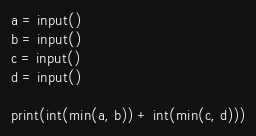Convert code to text. <code><loc_0><loc_0><loc_500><loc_500><_Python_>a = input()
b = input()
c = input()
d = input()

print(int(min(a, b)) + int(min(c, d)))</code> 